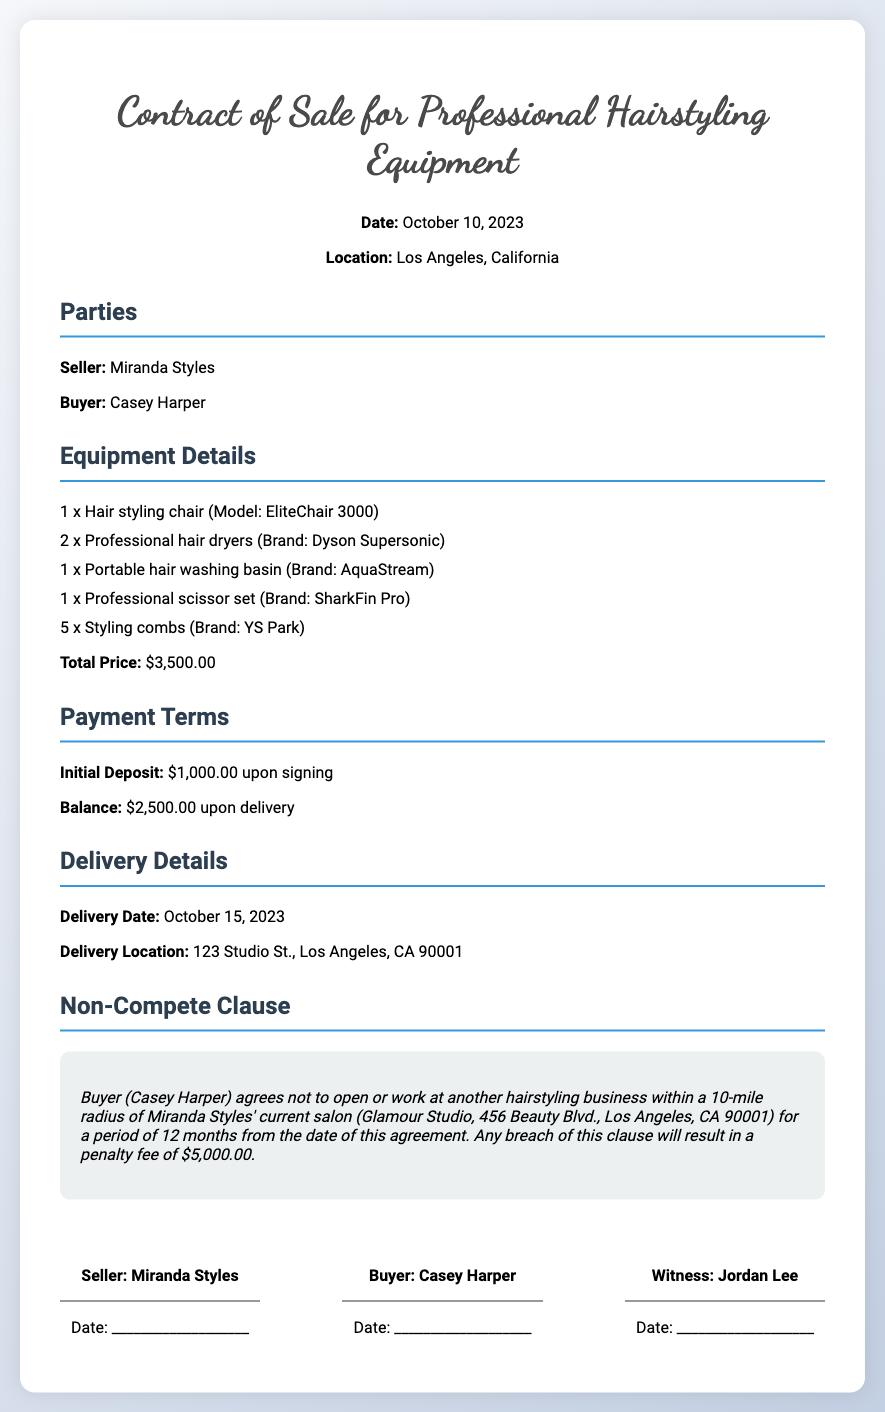What is the date of the contract? The date listed at the top of the document is October 10, 2023.
Answer: October 10, 2023 Who is the seller? The seller's name is provided in the Parties section of the contract.
Answer: Miranda Styles What is the total price of the equipment? The total price is mentioned in the Equipment Details section of the document.
Answer: $3,500.00 What is the initial deposit amount? The initial deposit amount is specified in the Payment Terms section of the contract.
Answer: $1,000.00 How many professional hair dryers are included in the sale? The number of professional hair dryers is listed in the Equipment Details section.
Answer: 2 What is the penalty fee for breaching the non-compete clause? The penalty fee for breach is indicated in the Non-Compete Clause section of the document.
Answer: $5,000.00 What radius is specified in the non-compete clause? The non-compete radius can be found in the Non-Compete Clause section of the contract.
Answer: 10-mile radius How long is the non-compete period? The duration of the non-compete period is stated in the Non-Compete Clause section.
Answer: 12 months What is the delivery address for the equipment? The delivery address is provided in the Delivery Details section of the contract.
Answer: 123 Studio St., Los Angeles, CA 90001 